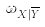<formula> <loc_0><loc_0><loc_500><loc_500>\omega _ { X | \overline { Y } }</formula> 